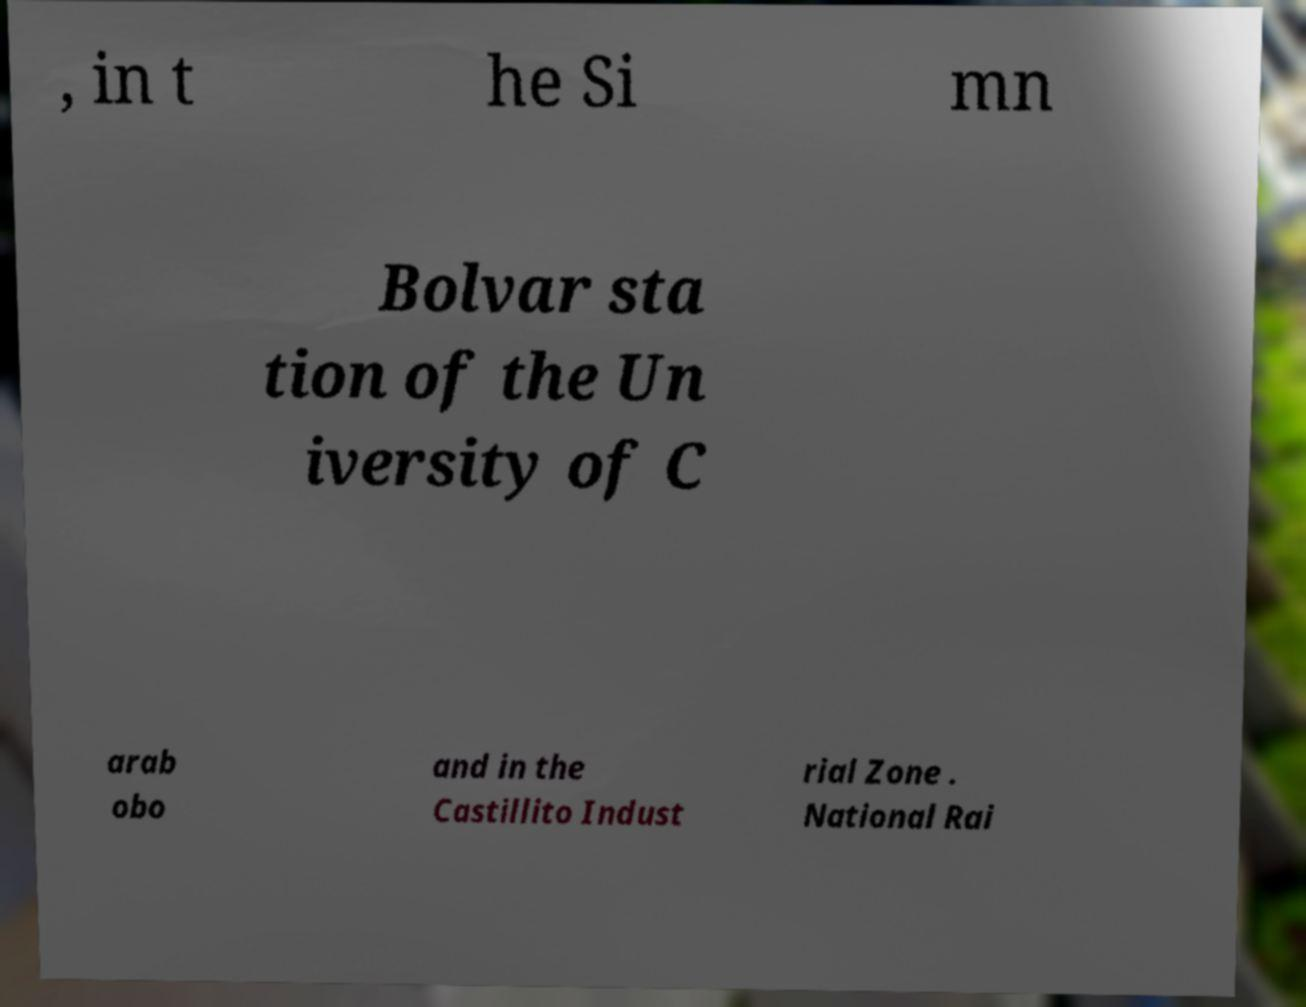Can you accurately transcribe the text from the provided image for me? , in t he Si mn Bolvar sta tion of the Un iversity of C arab obo and in the Castillito Indust rial Zone . National Rai 